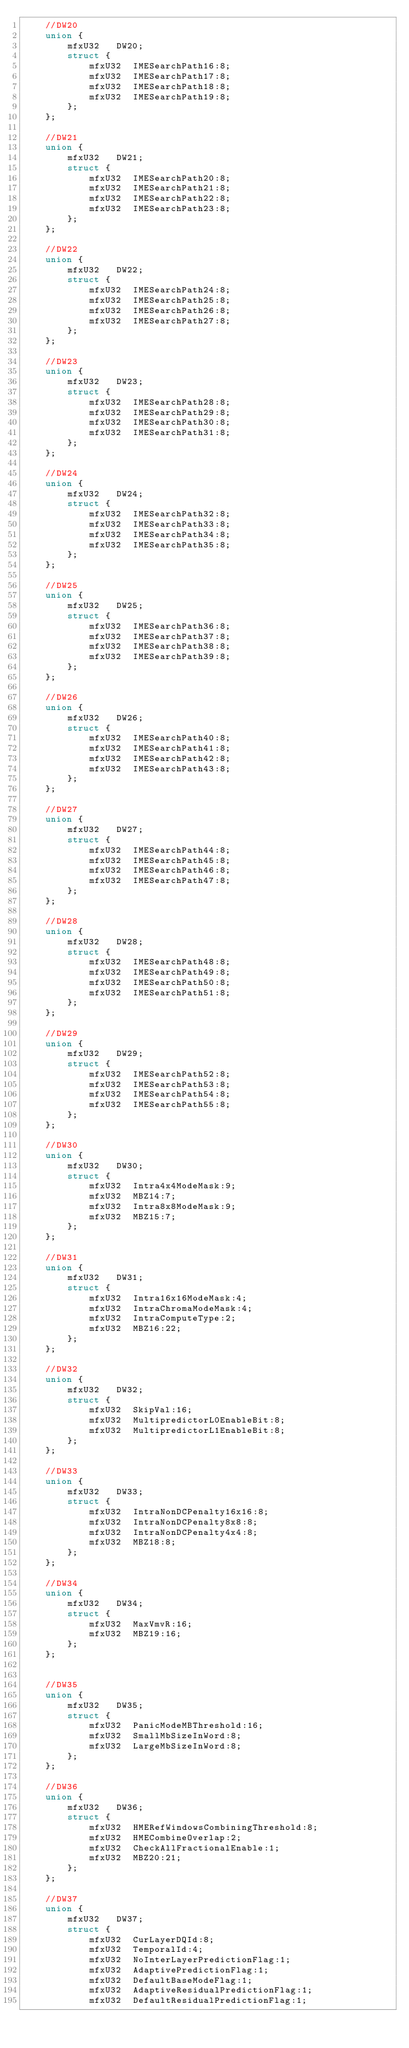<code> <loc_0><loc_0><loc_500><loc_500><_C_>    //DW20
    union {
        mfxU32   DW20;
        struct {
            mfxU32  IMESearchPath16:8;
            mfxU32  IMESearchPath17:8;
            mfxU32  IMESearchPath18:8;
            mfxU32  IMESearchPath19:8;
        };
    };

    //DW21
    union {
        mfxU32   DW21;
        struct {
            mfxU32  IMESearchPath20:8;
            mfxU32  IMESearchPath21:8;
            mfxU32  IMESearchPath22:8;
            mfxU32  IMESearchPath23:8;
        };
    };

    //DW22
    union {
        mfxU32   DW22;
        struct {
            mfxU32  IMESearchPath24:8;
            mfxU32  IMESearchPath25:8;
            mfxU32  IMESearchPath26:8;
            mfxU32  IMESearchPath27:8;
        };
    };

    //DW23
    union {
        mfxU32   DW23;
        struct {
            mfxU32  IMESearchPath28:8;
            mfxU32  IMESearchPath29:8;
            mfxU32  IMESearchPath30:8;
            mfxU32  IMESearchPath31:8;
        };
    };

    //DW24
    union {
        mfxU32   DW24;
        struct {
            mfxU32  IMESearchPath32:8;
            mfxU32  IMESearchPath33:8;
            mfxU32  IMESearchPath34:8;
            mfxU32  IMESearchPath35:8;
        };
    };

    //DW25
    union {
        mfxU32   DW25;
        struct {
            mfxU32  IMESearchPath36:8;
            mfxU32  IMESearchPath37:8;
            mfxU32  IMESearchPath38:8;
            mfxU32  IMESearchPath39:8;
        };
    };

    //DW26
    union {
        mfxU32   DW26;
        struct {
            mfxU32  IMESearchPath40:8;
            mfxU32  IMESearchPath41:8;
            mfxU32  IMESearchPath42:8;
            mfxU32  IMESearchPath43:8;
        };
    };

    //DW27
    union {
        mfxU32   DW27;
        struct {
            mfxU32  IMESearchPath44:8;
            mfxU32  IMESearchPath45:8;
            mfxU32  IMESearchPath46:8;
            mfxU32  IMESearchPath47:8;
        };
    };

    //DW28
    union {
        mfxU32   DW28;
        struct {
            mfxU32  IMESearchPath48:8;
            mfxU32  IMESearchPath49:8;
            mfxU32  IMESearchPath50:8;
            mfxU32  IMESearchPath51:8;
        };
    };

    //DW29
    union {
        mfxU32   DW29;
        struct {
            mfxU32  IMESearchPath52:8;
            mfxU32  IMESearchPath53:8;
            mfxU32  IMESearchPath54:8;
            mfxU32  IMESearchPath55:8;
        };
    };

    //DW30
    union {
        mfxU32   DW30;
        struct {
            mfxU32  Intra4x4ModeMask:9;
            mfxU32  MBZ14:7;
            mfxU32  Intra8x8ModeMask:9;
            mfxU32  MBZ15:7;
        };
    };

    //DW31
    union {
        mfxU32   DW31;
        struct {
            mfxU32  Intra16x16ModeMask:4;
            mfxU32  IntraChromaModeMask:4;
            mfxU32  IntraComputeType:2;
            mfxU32  MBZ16:22;
        };
    };

    //DW32
    union {
        mfxU32   DW32;
        struct {
            mfxU32  SkipVal:16;
            mfxU32  MultipredictorL0EnableBit:8;
            mfxU32  MultipredictorL1EnableBit:8;
        };
    };

    //DW33
    union {
        mfxU32   DW33;
        struct {
            mfxU32  IntraNonDCPenalty16x16:8;
            mfxU32  IntraNonDCPenalty8x8:8;
            mfxU32  IntraNonDCPenalty4x4:8;
            mfxU32  MBZ18:8;
        };
    };

    //DW34
    union {
        mfxU32   DW34;
        struct {
            mfxU32  MaxVmvR:16;
            mfxU32  MBZ19:16;
        };
    };


    //DW35
    union {
        mfxU32   DW35;
        struct {
            mfxU32  PanicModeMBThreshold:16;
            mfxU32  SmallMbSizeInWord:8;
            mfxU32  LargeMbSizeInWord:8;
        };
    };

    //DW36
    union {
        mfxU32   DW36;
        struct {
            mfxU32  HMERefWindowsCombiningThreshold:8;
            mfxU32  HMECombineOverlap:2;
            mfxU32  CheckAllFractionalEnable:1;
            mfxU32  MBZ20:21;
        };
    };

    //DW37
    union {
        mfxU32   DW37;
        struct {
            mfxU32  CurLayerDQId:8;
            mfxU32  TemporalId:4;
            mfxU32  NoInterLayerPredictionFlag:1;
            mfxU32  AdaptivePredictionFlag:1;
            mfxU32  DefaultBaseModeFlag:1;
            mfxU32  AdaptiveResidualPredictionFlag:1;
            mfxU32  DefaultResidualPredictionFlag:1;</code> 